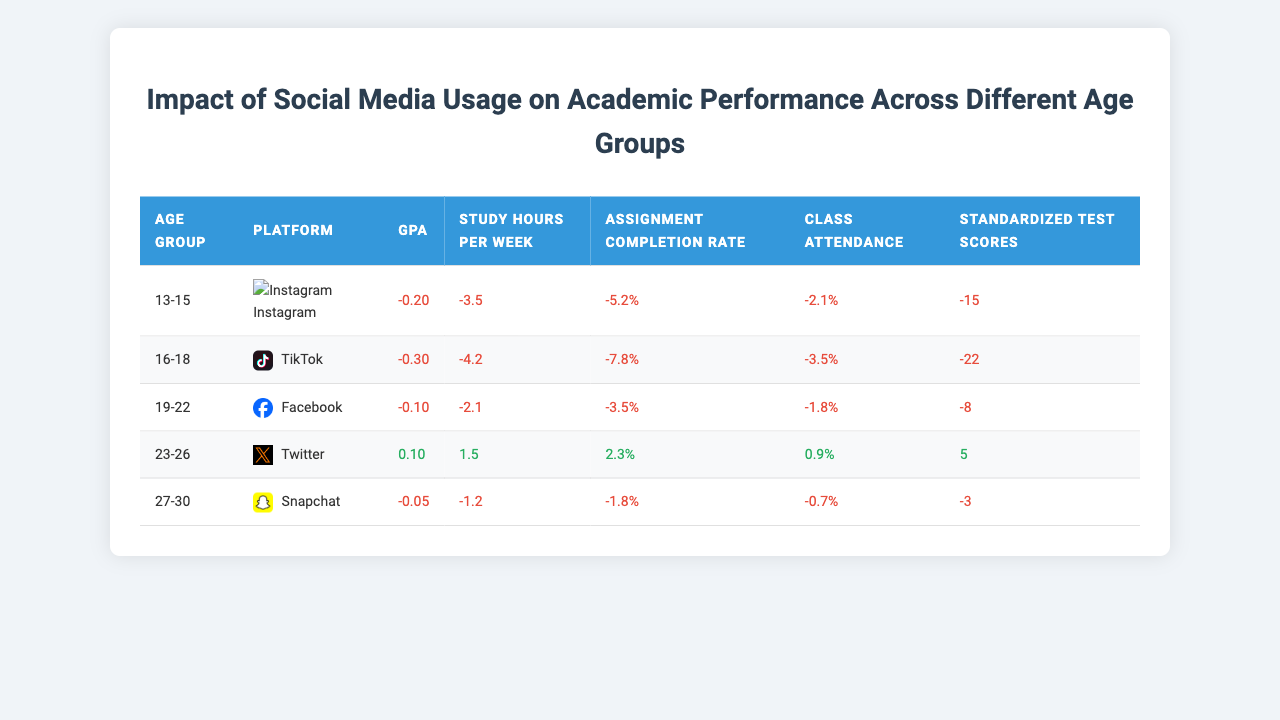What is the GPA change for the age group 13-15 using Instagram? The table shows that the GPA for the age group 13-15 using Instagram is -0.2, indicating a decrease.
Answer: -0.2 Which social media platform corresponds to the highest negative impact on Class Attendance for the age group 16-18? The table indicates that TikTok has a Class Attendance change of -3.5, which is the lowest among platforms listed for that age group.
Answer: TikTok What is the average change in Standardized Test Scores across all age groups and platforms? Summing the Standardized Test Scores: -15 + -22 + -8 + 5 + -3 = -43. There are 5 age groups, so the average is -43 / 5 = -8.6.
Answer: -8.6 Is there any age group in which social media usage leads to positive changes in academic performance? For the age group 23-26 using Twitter, all performance metrics show positive values: GPA (0.1), Study Hours Per Week (1.5), Assignment Completion Rate (2.3), Class Attendance (0.9), and Standardized Test Scores (5), indicating improvement.
Answer: Yes Which age group shows the least negative impact on Assignment Completion Rate and what is the value? The age group 19-22 using Facebook shows the least negative impact with an Assignment Completion Rate change of -3.5, compared to other age groups which have more negative values.
Answer: -3.5 If we consider the 23-26 age group using Twitter, how does the change in GPA compare to the change in Study Hours Per Week? The GPA change is 0.1, while the Study Hours Per Week change is 1.5. Both values are positive, but the change in Study Hours Per Week (1.5) is greater than the GPA change (0.1).
Answer: Study Hours Per Week change (1.5) is greater For the 27-30 age group using Snapchat, what is the total change when adding the values of Study Hours Per Week, Assignment Completion Rate, and Class Attendance? Summing these values: -1.2 + -1.8 + -0.7 results in a total change of -3.7.
Answer: -3.7 Is the average change across all platforms for the age group 19-22 positive or negative? The changes for that age group are GPA (-0.1), Study Hours Per Week (-2.1), Assignment Completion Rate (-3.5), Class Attendance (-1.8), and Standardized Test Scores (-8). All values are negative, resulting in an overall negative impact.
Answer: Negative How does the GPA change for the 16-18 age group using TikTok compare to the change in Standardized Test Scores? The GPA change is -0.3 while the Standardized Test Scores change is -22, indicating that the Standardized Test Scores have a larger negative change compared to the GPA.
Answer: Greater negative change in Standardized Test Scores (-22) 